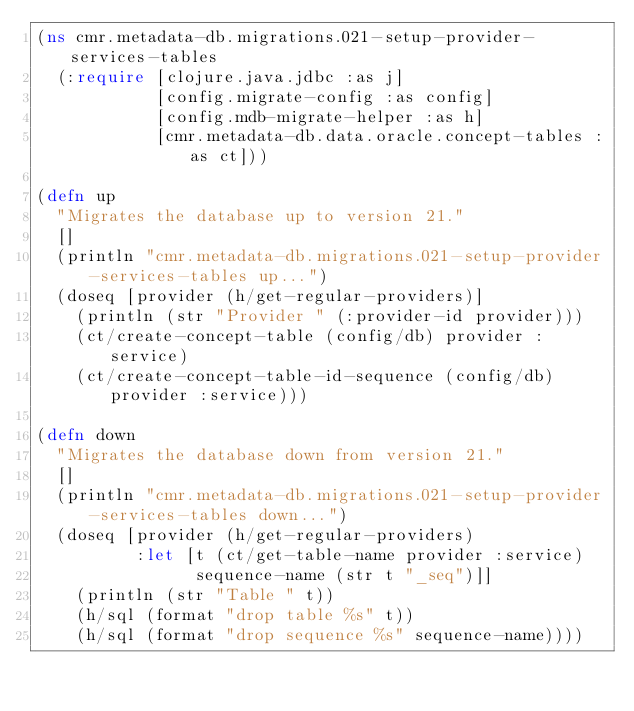<code> <loc_0><loc_0><loc_500><loc_500><_Clojure_>(ns cmr.metadata-db.migrations.021-setup-provider-services-tables
  (:require [clojure.java.jdbc :as j]
            [config.migrate-config :as config]
            [config.mdb-migrate-helper :as h]
            [cmr.metadata-db.data.oracle.concept-tables :as ct]))

(defn up
  "Migrates the database up to version 21."
  []
  (println "cmr.metadata-db.migrations.021-setup-provider-services-tables up...")
  (doseq [provider (h/get-regular-providers)]
    (println (str "Provider " (:provider-id provider)))
    (ct/create-concept-table (config/db) provider :service)
    (ct/create-concept-table-id-sequence (config/db) provider :service)))

(defn down
  "Migrates the database down from version 21."
  []
  (println "cmr.metadata-db.migrations.021-setup-provider-services-tables down...")
  (doseq [provider (h/get-regular-providers)
          :let [t (ct/get-table-name provider :service)
                sequence-name (str t "_seq")]]
    (println (str "Table " t))
    (h/sql (format "drop table %s" t))
    (h/sql (format "drop sequence %s" sequence-name))))</code> 